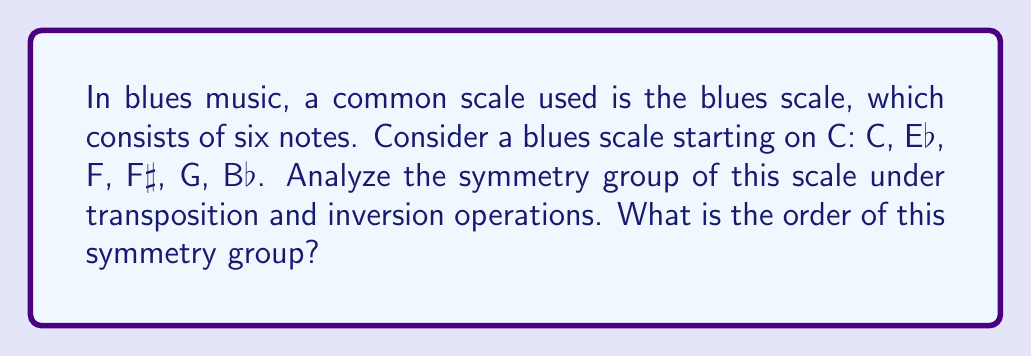Solve this math problem. To analyze the symmetry group of the blues scale, we need to consider two types of operations:

1. Transposition: Shifting all notes by the same interval.
2. Inversion: Reflecting the scale around a fixed point.

Let's examine these operations:

1. Transpositions:
   There are 12 possible transpositions (including the identity), corresponding to the 12 semitones in an octave. However, not all of these will preserve the structure of the blues scale.

   The blues scale has the following interval structure: 
   $$(0, 3, 5, 6, 7, 10)$$

   To preserve this structure, we need to find transpositions that map the scale onto itself. The only such transposition is the identity (T0).

2. Inversions:
   There are 12 possible inversions, each centered on a different pitch class. However, like transpositions, not all of these will preserve the structure of the blues scale.

   To find valid inversions, we need to check which ones map the scale onto itself. Let's represent inversion around pitch class n as In.

   $$I_0(0, 3, 5, 6, 7, 10) = (0, 9, 7, 6, 5, 2)$$
   $$I_6(0, 3, 5, 6, 7, 10) = (0, 9, 7, 6, 5, 2)$$

   We can see that I0 and I6 produce the same result, which is a permutation of the original scale.

Therefore, the symmetry group of the blues scale consists of two elements:
1. The identity operation (T0)
2. The inversion operation (I0 or I6, which are equivalent in this context)

This group has two elements and is isomorphic to the cyclic group of order 2, C2, or equivalently, the symmetry group of a rectangle, D1.

The order of a group is the number of elements in the group. In this case, the order is 2.
Answer: The order of the symmetry group of the blues scale is 2. 